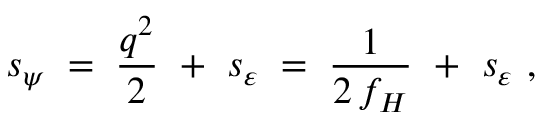<formula> <loc_0><loc_0><loc_500><loc_500>s _ { \psi } \, = \, \frac { q ^ { 2 } } { 2 } + s _ { \varepsilon } \, = \, \frac { 1 } { 2 \, f _ { H } } + s _ { \varepsilon } ,</formula> 